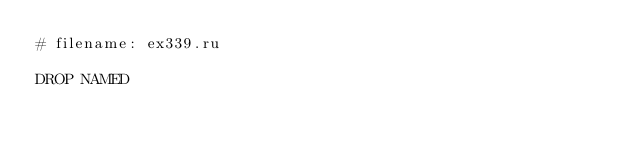Convert code to text. <code><loc_0><loc_0><loc_500><loc_500><_Ruby_># filename: ex339.ru

DROP NAMED

</code> 